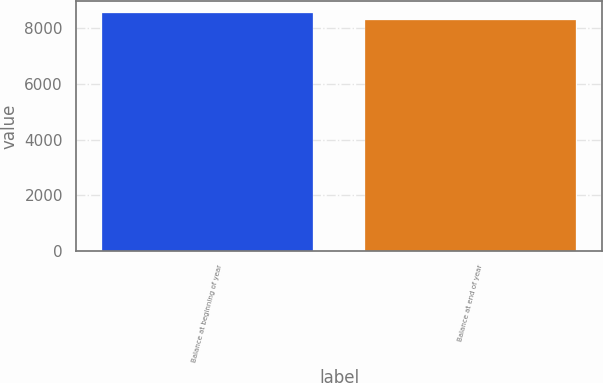Convert chart. <chart><loc_0><loc_0><loc_500><loc_500><bar_chart><fcel>Balance at beginning of year<fcel>Balance at end of year<nl><fcel>8568<fcel>8311<nl></chart> 